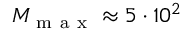Convert formula to latex. <formula><loc_0><loc_0><loc_500><loc_500>M _ { m a x } \approx 5 \cdot 1 0 ^ { 2 }</formula> 